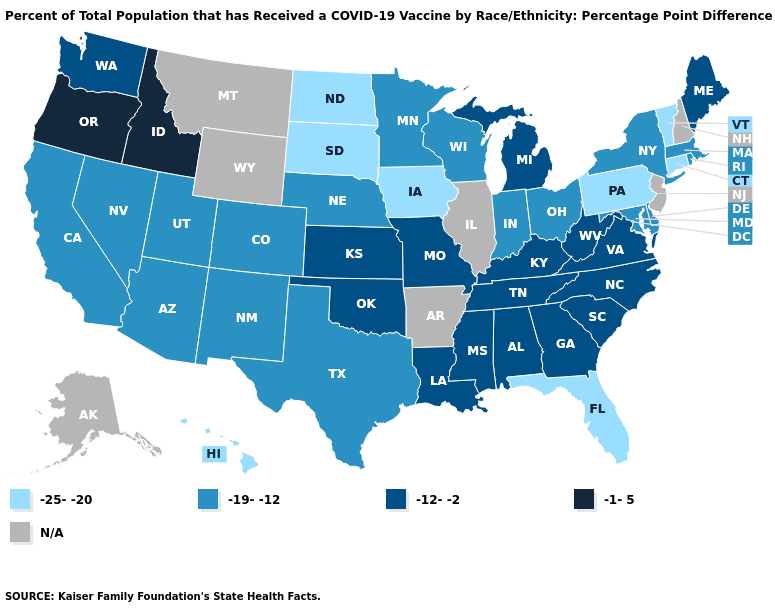Among the states that border Massachusetts , does Vermont have the lowest value?
Quick response, please. Yes. Name the states that have a value in the range -25--20?
Answer briefly. Connecticut, Florida, Hawaii, Iowa, North Dakota, Pennsylvania, South Dakota, Vermont. What is the highest value in the USA?
Give a very brief answer. -1-5. What is the lowest value in the USA?
Concise answer only. -25--20. What is the value of Nevada?
Quick response, please. -19--12. Does Iowa have the lowest value in the MidWest?
Answer briefly. Yes. Name the states that have a value in the range -19--12?
Concise answer only. Arizona, California, Colorado, Delaware, Indiana, Maryland, Massachusetts, Minnesota, Nebraska, Nevada, New Mexico, New York, Ohio, Rhode Island, Texas, Utah, Wisconsin. What is the value of Texas?
Short answer required. -19--12. Does the first symbol in the legend represent the smallest category?
Be succinct. Yes. Among the states that border Indiana , which have the lowest value?
Quick response, please. Ohio. What is the value of Colorado?
Write a very short answer. -19--12. What is the value of Nebraska?
Be succinct. -19--12. What is the value of Louisiana?
Concise answer only. -12--2. Name the states that have a value in the range -19--12?
Quick response, please. Arizona, California, Colorado, Delaware, Indiana, Maryland, Massachusetts, Minnesota, Nebraska, Nevada, New Mexico, New York, Ohio, Rhode Island, Texas, Utah, Wisconsin. What is the highest value in the MidWest ?
Quick response, please. -12--2. 